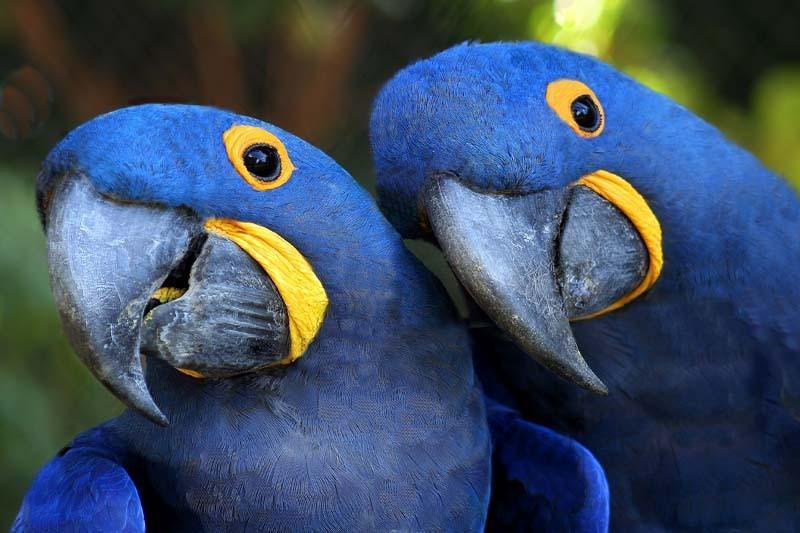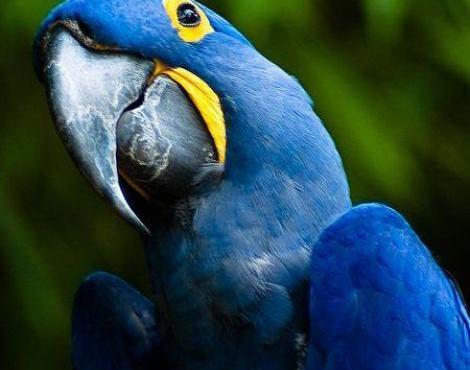The first image is the image on the left, the second image is the image on the right. Assess this claim about the two images: "There are two birds". Correct or not? Answer yes or no. No. 